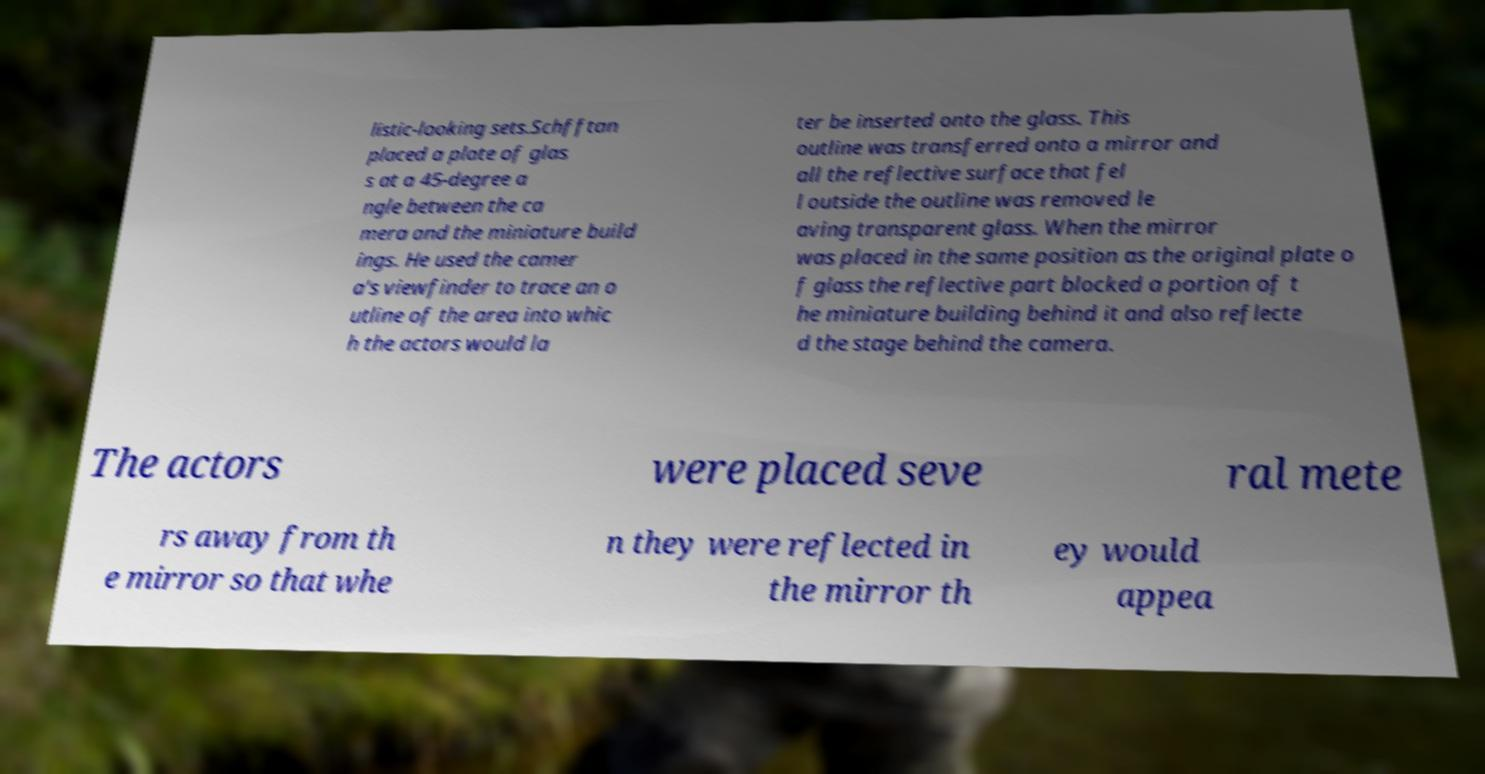For documentation purposes, I need the text within this image transcribed. Could you provide that? listic-looking sets.Schfftan placed a plate of glas s at a 45-degree a ngle between the ca mera and the miniature build ings. He used the camer a's viewfinder to trace an o utline of the area into whic h the actors would la ter be inserted onto the glass. This outline was transferred onto a mirror and all the reflective surface that fel l outside the outline was removed le aving transparent glass. When the mirror was placed in the same position as the original plate o f glass the reflective part blocked a portion of t he miniature building behind it and also reflecte d the stage behind the camera. The actors were placed seve ral mete rs away from th e mirror so that whe n they were reflected in the mirror th ey would appea 